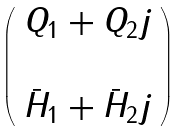Convert formula to latex. <formula><loc_0><loc_0><loc_500><loc_500>\left ( \begin{array} { c c } Q _ { 1 } + Q _ { 2 } j \\ \\ \bar { H } _ { 1 } + \bar { H } _ { 2 } j \end{array} \right )</formula> 